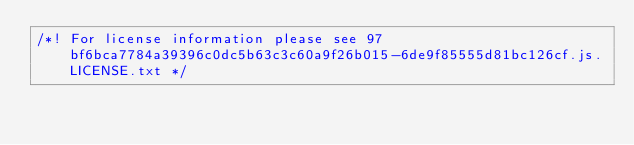<code> <loc_0><loc_0><loc_500><loc_500><_JavaScript_>/*! For license information please see 97bf6bca7784a39396c0dc5b63c3c60a9f26b015-6de9f85555d81bc126cf.js.LICENSE.txt */</code> 